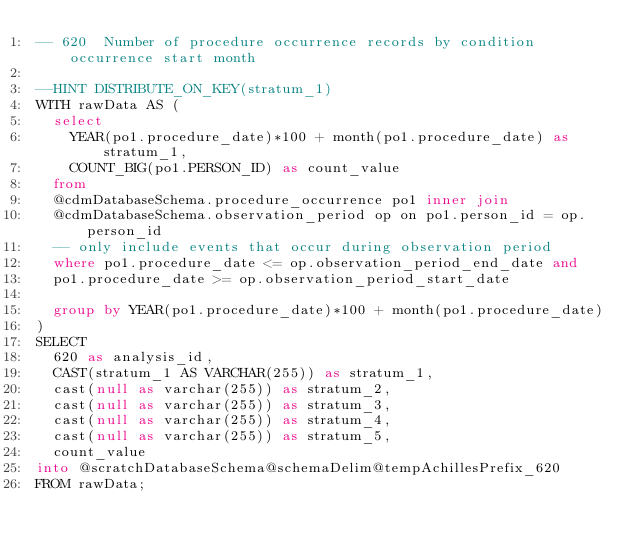<code> <loc_0><loc_0><loc_500><loc_500><_SQL_>-- 620	Number of procedure occurrence records by condition occurrence start month

--HINT DISTRIBUTE_ON_KEY(stratum_1)
WITH rawData AS (
  select
    YEAR(po1.procedure_date)*100 + month(po1.procedure_date) as stratum_1,
    COUNT_BIG(po1.PERSON_ID) as count_value
  from
  @cdmDatabaseSchema.procedure_occurrence po1 inner join 
  @cdmDatabaseSchema.observation_period op on po1.person_id = op.person_id
  -- only include events that occur during observation period
  where po1.procedure_date <= op.observation_period_end_date and
  po1.procedure_date >= op.observation_period_start_date
  
  group by YEAR(po1.procedure_date)*100 + month(po1.procedure_date)
)
SELECT
  620 as analysis_id,
  CAST(stratum_1 AS VARCHAR(255)) as stratum_1,
  cast(null as varchar(255)) as stratum_2,
  cast(null as varchar(255)) as stratum_3,
  cast(null as varchar(255)) as stratum_4,
  cast(null as varchar(255)) as stratum_5,
  count_value
into @scratchDatabaseSchema@schemaDelim@tempAchillesPrefix_620
FROM rawData;
</code> 